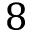Convert formula to latex. <formula><loc_0><loc_0><loc_500><loc_500>8</formula> 